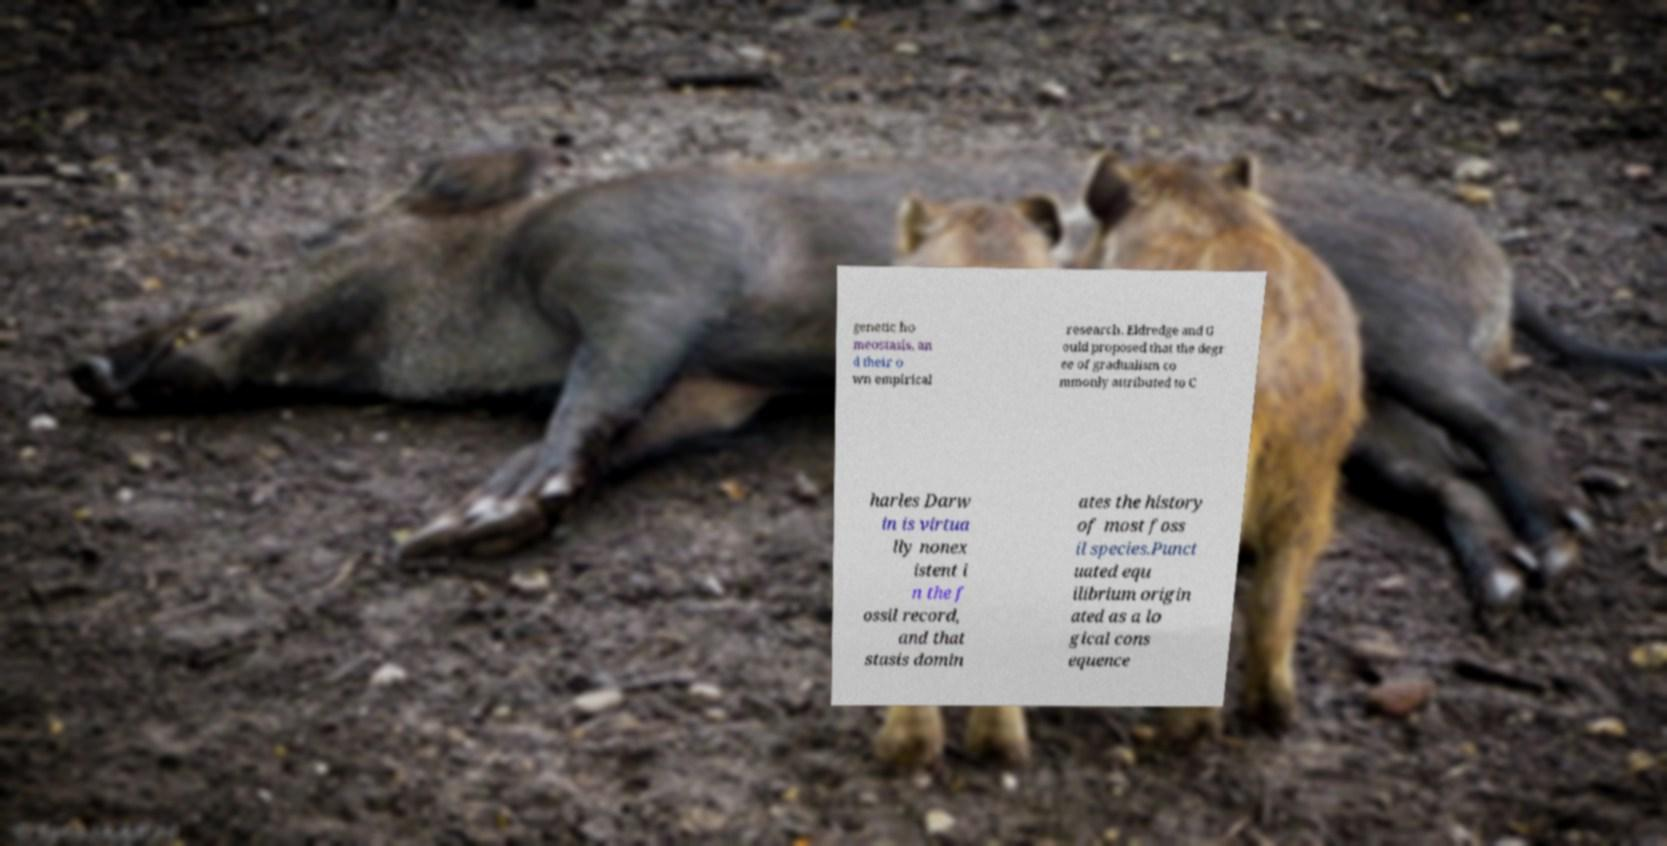Can you accurately transcribe the text from the provided image for me? genetic ho meostasis, an d their o wn empirical research. Eldredge and G ould proposed that the degr ee of gradualism co mmonly attributed to C harles Darw in is virtua lly nonex istent i n the f ossil record, and that stasis domin ates the history of most foss il species.Punct uated equ ilibrium origin ated as a lo gical cons equence 